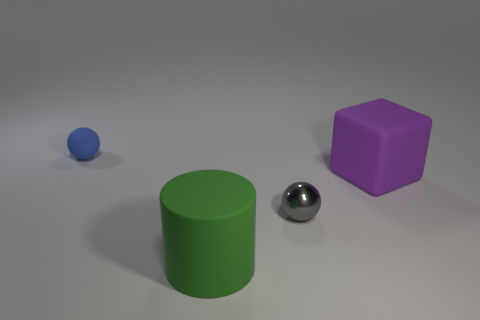Add 2 rubber objects. How many objects exist? 6 Subtract all blue spheres. How many spheres are left? 1 Subtract all brown cylinders. Subtract all purple cubes. How many cylinders are left? 1 Subtract all small gray things. Subtract all rubber cubes. How many objects are left? 2 Add 1 tiny gray shiny spheres. How many tiny gray shiny spheres are left? 2 Add 1 brown metallic cylinders. How many brown metallic cylinders exist? 1 Subtract 0 blue cylinders. How many objects are left? 4 Subtract all cylinders. How many objects are left? 3 Subtract 1 cylinders. How many cylinders are left? 0 